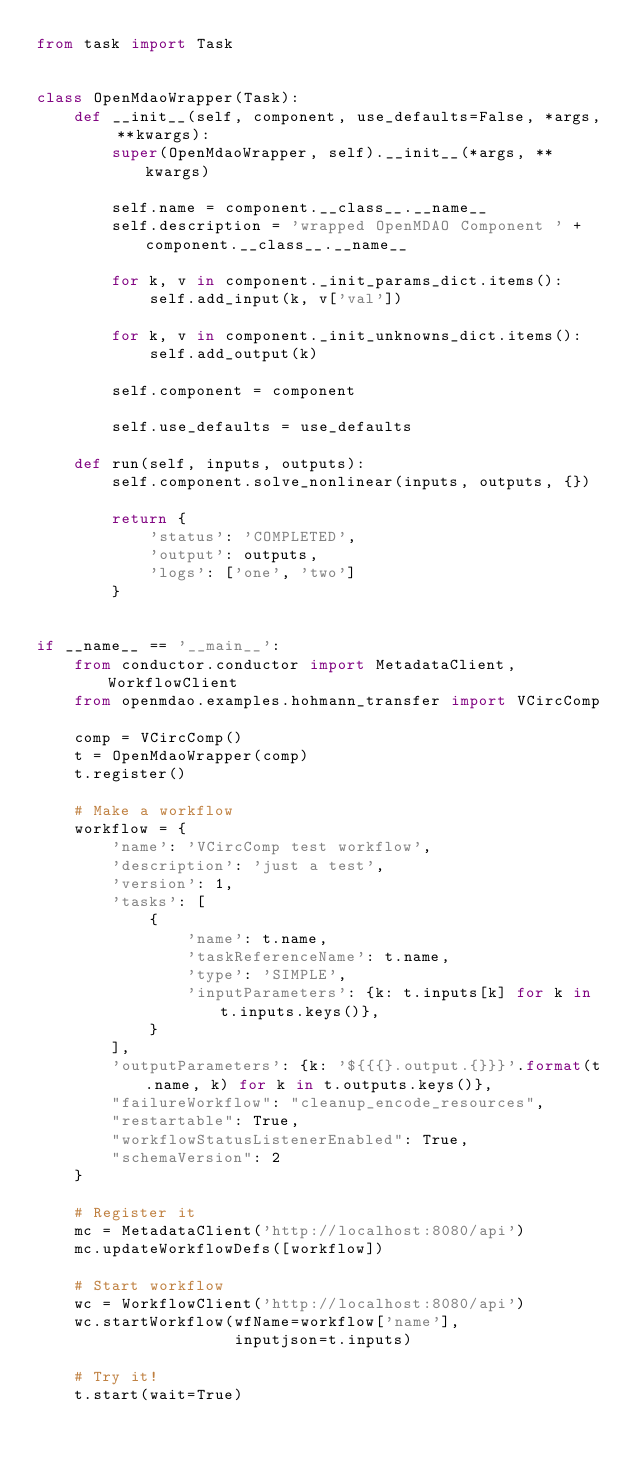<code> <loc_0><loc_0><loc_500><loc_500><_Python_>from task import Task


class OpenMdaoWrapper(Task):
    def __init__(self, component, use_defaults=False, *args, **kwargs):
        super(OpenMdaoWrapper, self).__init__(*args, **kwargs)

        self.name = component.__class__.__name__
        self.description = 'wrapped OpenMDAO Component ' + component.__class__.__name__

        for k, v in component._init_params_dict.items():
            self.add_input(k, v['val'])

        for k, v in component._init_unknowns_dict.items():
            self.add_output(k)

        self.component = component

        self.use_defaults = use_defaults

    def run(self, inputs, outputs):
        self.component.solve_nonlinear(inputs, outputs, {})

        return {
            'status': 'COMPLETED',
            'output': outputs,
            'logs': ['one', 'two']
        }


if __name__ == '__main__':
    from conductor.conductor import MetadataClient, WorkflowClient
    from openmdao.examples.hohmann_transfer import VCircComp

    comp = VCircComp()
    t = OpenMdaoWrapper(comp)
    t.register()

    # Make a workflow
    workflow = {
        'name': 'VCircComp test workflow',
        'description': 'just a test',
        'version': 1,
        'tasks': [
            {
                'name': t.name,
                'taskReferenceName': t.name,
                'type': 'SIMPLE',
                'inputParameters': {k: t.inputs[k] for k in t.inputs.keys()},
            }
        ],
        'outputParameters': {k: '${{{}.output.{}}}'.format(t.name, k) for k in t.outputs.keys()},
        "failureWorkflow": "cleanup_encode_resources",
        "restartable": True,
        "workflowStatusListenerEnabled": True,
        "schemaVersion": 2
    }

    # Register it
    mc = MetadataClient('http://localhost:8080/api')
    mc.updateWorkflowDefs([workflow])

    # Start workflow
    wc = WorkflowClient('http://localhost:8080/api')
    wc.startWorkflow(wfName=workflow['name'],
                     inputjson=t.inputs)

    # Try it!
    t.start(wait=True)
</code> 